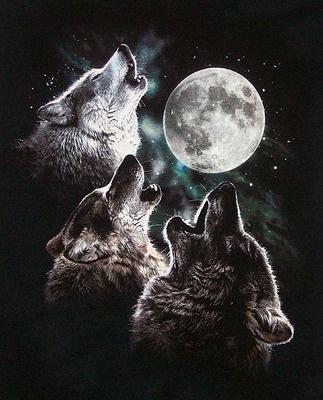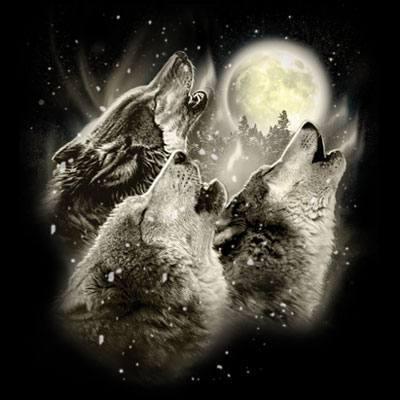The first image is the image on the left, the second image is the image on the right. Considering the images on both sides, is "The left image includes a moon, clouds, and a howling wolf figure, and the right image depicts a forward-facing snarling wolf." valid? Answer yes or no. No. The first image is the image on the left, the second image is the image on the right. Analyze the images presented: Is the assertion "A single wolf is howling and silhouetted by the moon in one of the images." valid? Answer yes or no. No. 